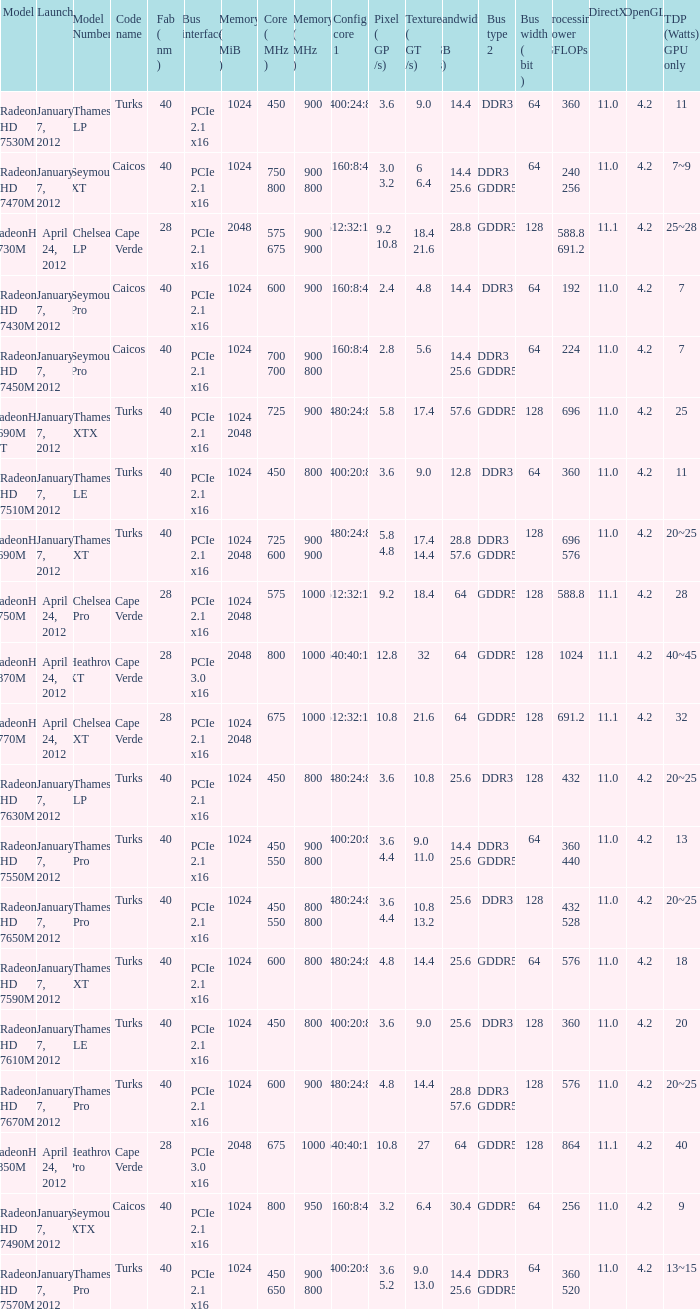What is the config core 1 of the model with a processing power GFLOPs of 432? 480:24:8. 